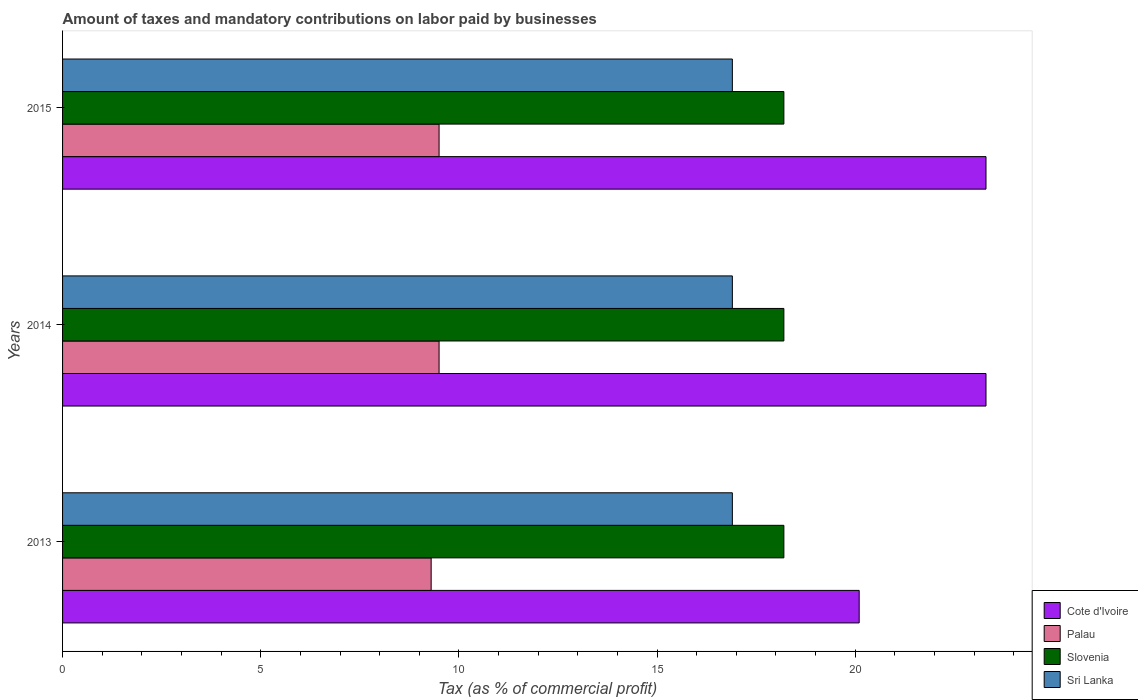Are the number of bars per tick equal to the number of legend labels?
Your answer should be compact. Yes. How many bars are there on the 3rd tick from the bottom?
Provide a succinct answer. 4. In how many cases, is the number of bars for a given year not equal to the number of legend labels?
Your answer should be very brief. 0. What is the percentage of taxes paid by businesses in Cote d'Ivoire in 2013?
Give a very brief answer. 20.1. Across all years, what is the maximum percentage of taxes paid by businesses in Sri Lanka?
Ensure brevity in your answer.  16.9. Across all years, what is the minimum percentage of taxes paid by businesses in Sri Lanka?
Your response must be concise. 16.9. What is the total percentage of taxes paid by businesses in Palau in the graph?
Offer a very short reply. 28.3. What is the difference between the percentage of taxes paid by businesses in Palau in 2013 and that in 2014?
Offer a terse response. -0.2. What is the difference between the percentage of taxes paid by businesses in Cote d'Ivoire in 2013 and the percentage of taxes paid by businesses in Slovenia in 2015?
Keep it short and to the point. 1.9. What is the average percentage of taxes paid by businesses in Cote d'Ivoire per year?
Your answer should be very brief. 22.23. In the year 2014, what is the difference between the percentage of taxes paid by businesses in Slovenia and percentage of taxes paid by businesses in Palau?
Your answer should be very brief. 8.7. Is the percentage of taxes paid by businesses in Cote d'Ivoire in 2013 less than that in 2014?
Your response must be concise. Yes. Is the difference between the percentage of taxes paid by businesses in Slovenia in 2014 and 2015 greater than the difference between the percentage of taxes paid by businesses in Palau in 2014 and 2015?
Offer a very short reply. No. What is the difference between the highest and the second highest percentage of taxes paid by businesses in Cote d'Ivoire?
Make the answer very short. 0. What is the difference between the highest and the lowest percentage of taxes paid by businesses in Cote d'Ivoire?
Make the answer very short. 3.2. Is the sum of the percentage of taxes paid by businesses in Palau in 2013 and 2014 greater than the maximum percentage of taxes paid by businesses in Cote d'Ivoire across all years?
Offer a terse response. No. What does the 4th bar from the top in 2015 represents?
Offer a very short reply. Cote d'Ivoire. What does the 4th bar from the bottom in 2013 represents?
Provide a succinct answer. Sri Lanka. Is it the case that in every year, the sum of the percentage of taxes paid by businesses in Cote d'Ivoire and percentage of taxes paid by businesses in Slovenia is greater than the percentage of taxes paid by businesses in Sri Lanka?
Ensure brevity in your answer.  Yes. How many bars are there?
Offer a terse response. 12. Are all the bars in the graph horizontal?
Keep it short and to the point. Yes. Are the values on the major ticks of X-axis written in scientific E-notation?
Your answer should be very brief. No. Does the graph contain any zero values?
Keep it short and to the point. No. Does the graph contain grids?
Your answer should be very brief. No. How are the legend labels stacked?
Your response must be concise. Vertical. What is the title of the graph?
Provide a short and direct response. Amount of taxes and mandatory contributions on labor paid by businesses. Does "Benin" appear as one of the legend labels in the graph?
Provide a short and direct response. No. What is the label or title of the X-axis?
Ensure brevity in your answer.  Tax (as % of commercial profit). What is the Tax (as % of commercial profit) in Cote d'Ivoire in 2013?
Give a very brief answer. 20.1. What is the Tax (as % of commercial profit) of Palau in 2013?
Offer a terse response. 9.3. What is the Tax (as % of commercial profit) of Slovenia in 2013?
Offer a terse response. 18.2. What is the Tax (as % of commercial profit) of Cote d'Ivoire in 2014?
Offer a terse response. 23.3. What is the Tax (as % of commercial profit) in Sri Lanka in 2014?
Offer a terse response. 16.9. What is the Tax (as % of commercial profit) of Cote d'Ivoire in 2015?
Offer a terse response. 23.3. What is the Tax (as % of commercial profit) in Palau in 2015?
Your response must be concise. 9.5. What is the Tax (as % of commercial profit) of Sri Lanka in 2015?
Offer a very short reply. 16.9. Across all years, what is the maximum Tax (as % of commercial profit) in Cote d'Ivoire?
Your response must be concise. 23.3. Across all years, what is the maximum Tax (as % of commercial profit) in Palau?
Your response must be concise. 9.5. Across all years, what is the maximum Tax (as % of commercial profit) of Sri Lanka?
Provide a succinct answer. 16.9. Across all years, what is the minimum Tax (as % of commercial profit) in Cote d'Ivoire?
Provide a short and direct response. 20.1. Across all years, what is the minimum Tax (as % of commercial profit) in Slovenia?
Provide a succinct answer. 18.2. What is the total Tax (as % of commercial profit) in Cote d'Ivoire in the graph?
Make the answer very short. 66.7. What is the total Tax (as % of commercial profit) of Palau in the graph?
Your answer should be very brief. 28.3. What is the total Tax (as % of commercial profit) of Slovenia in the graph?
Give a very brief answer. 54.6. What is the total Tax (as % of commercial profit) in Sri Lanka in the graph?
Make the answer very short. 50.7. What is the difference between the Tax (as % of commercial profit) of Palau in 2013 and that in 2014?
Offer a terse response. -0.2. What is the difference between the Tax (as % of commercial profit) in Slovenia in 2013 and that in 2014?
Your answer should be very brief. 0. What is the difference between the Tax (as % of commercial profit) of Sri Lanka in 2013 and that in 2014?
Make the answer very short. 0. What is the difference between the Tax (as % of commercial profit) in Slovenia in 2013 and that in 2015?
Make the answer very short. 0. What is the difference between the Tax (as % of commercial profit) in Slovenia in 2014 and that in 2015?
Provide a short and direct response. 0. What is the difference between the Tax (as % of commercial profit) in Cote d'Ivoire in 2013 and the Tax (as % of commercial profit) in Palau in 2014?
Give a very brief answer. 10.6. What is the difference between the Tax (as % of commercial profit) in Cote d'Ivoire in 2013 and the Tax (as % of commercial profit) in Slovenia in 2014?
Provide a succinct answer. 1.9. What is the difference between the Tax (as % of commercial profit) in Palau in 2013 and the Tax (as % of commercial profit) in Slovenia in 2014?
Your answer should be very brief. -8.9. What is the difference between the Tax (as % of commercial profit) of Slovenia in 2013 and the Tax (as % of commercial profit) of Sri Lanka in 2014?
Offer a very short reply. 1.3. What is the difference between the Tax (as % of commercial profit) in Cote d'Ivoire in 2013 and the Tax (as % of commercial profit) in Palau in 2015?
Offer a terse response. 10.6. What is the difference between the Tax (as % of commercial profit) of Cote d'Ivoire in 2013 and the Tax (as % of commercial profit) of Slovenia in 2015?
Ensure brevity in your answer.  1.9. What is the difference between the Tax (as % of commercial profit) of Cote d'Ivoire in 2013 and the Tax (as % of commercial profit) of Sri Lanka in 2015?
Make the answer very short. 3.2. What is the difference between the Tax (as % of commercial profit) of Palau in 2013 and the Tax (as % of commercial profit) of Slovenia in 2015?
Provide a succinct answer. -8.9. What is the difference between the Tax (as % of commercial profit) of Palau in 2013 and the Tax (as % of commercial profit) of Sri Lanka in 2015?
Ensure brevity in your answer.  -7.6. What is the difference between the Tax (as % of commercial profit) in Slovenia in 2013 and the Tax (as % of commercial profit) in Sri Lanka in 2015?
Make the answer very short. 1.3. What is the difference between the Tax (as % of commercial profit) in Cote d'Ivoire in 2014 and the Tax (as % of commercial profit) in Sri Lanka in 2015?
Provide a short and direct response. 6.4. What is the difference between the Tax (as % of commercial profit) in Palau in 2014 and the Tax (as % of commercial profit) in Sri Lanka in 2015?
Offer a terse response. -7.4. What is the average Tax (as % of commercial profit) in Cote d'Ivoire per year?
Keep it short and to the point. 22.23. What is the average Tax (as % of commercial profit) of Palau per year?
Give a very brief answer. 9.43. What is the average Tax (as % of commercial profit) in Slovenia per year?
Provide a succinct answer. 18.2. What is the average Tax (as % of commercial profit) of Sri Lanka per year?
Offer a very short reply. 16.9. In the year 2013, what is the difference between the Tax (as % of commercial profit) in Cote d'Ivoire and Tax (as % of commercial profit) in Palau?
Your answer should be very brief. 10.8. In the year 2013, what is the difference between the Tax (as % of commercial profit) in Cote d'Ivoire and Tax (as % of commercial profit) in Slovenia?
Make the answer very short. 1.9. In the year 2013, what is the difference between the Tax (as % of commercial profit) of Cote d'Ivoire and Tax (as % of commercial profit) of Sri Lanka?
Offer a very short reply. 3.2. In the year 2013, what is the difference between the Tax (as % of commercial profit) of Palau and Tax (as % of commercial profit) of Sri Lanka?
Ensure brevity in your answer.  -7.6. In the year 2013, what is the difference between the Tax (as % of commercial profit) of Slovenia and Tax (as % of commercial profit) of Sri Lanka?
Keep it short and to the point. 1.3. In the year 2014, what is the difference between the Tax (as % of commercial profit) in Cote d'Ivoire and Tax (as % of commercial profit) in Palau?
Provide a succinct answer. 13.8. In the year 2014, what is the difference between the Tax (as % of commercial profit) of Cote d'Ivoire and Tax (as % of commercial profit) of Slovenia?
Give a very brief answer. 5.1. In the year 2014, what is the difference between the Tax (as % of commercial profit) of Cote d'Ivoire and Tax (as % of commercial profit) of Sri Lanka?
Make the answer very short. 6.4. In the year 2014, what is the difference between the Tax (as % of commercial profit) in Palau and Tax (as % of commercial profit) in Slovenia?
Keep it short and to the point. -8.7. In the year 2014, what is the difference between the Tax (as % of commercial profit) of Palau and Tax (as % of commercial profit) of Sri Lanka?
Provide a short and direct response. -7.4. In the year 2015, what is the difference between the Tax (as % of commercial profit) of Palau and Tax (as % of commercial profit) of Sri Lanka?
Provide a succinct answer. -7.4. What is the ratio of the Tax (as % of commercial profit) in Cote d'Ivoire in 2013 to that in 2014?
Provide a succinct answer. 0.86. What is the ratio of the Tax (as % of commercial profit) of Palau in 2013 to that in 2014?
Provide a succinct answer. 0.98. What is the ratio of the Tax (as % of commercial profit) of Slovenia in 2013 to that in 2014?
Your answer should be compact. 1. What is the ratio of the Tax (as % of commercial profit) of Cote d'Ivoire in 2013 to that in 2015?
Offer a very short reply. 0.86. What is the ratio of the Tax (as % of commercial profit) in Palau in 2013 to that in 2015?
Ensure brevity in your answer.  0.98. What is the ratio of the Tax (as % of commercial profit) of Slovenia in 2013 to that in 2015?
Make the answer very short. 1. What is the ratio of the Tax (as % of commercial profit) of Sri Lanka in 2013 to that in 2015?
Offer a terse response. 1. What is the ratio of the Tax (as % of commercial profit) in Cote d'Ivoire in 2014 to that in 2015?
Provide a short and direct response. 1. What is the ratio of the Tax (as % of commercial profit) in Sri Lanka in 2014 to that in 2015?
Offer a very short reply. 1. What is the difference between the highest and the second highest Tax (as % of commercial profit) in Palau?
Your response must be concise. 0. What is the difference between the highest and the lowest Tax (as % of commercial profit) in Cote d'Ivoire?
Your answer should be very brief. 3.2. What is the difference between the highest and the lowest Tax (as % of commercial profit) of Slovenia?
Offer a terse response. 0. What is the difference between the highest and the lowest Tax (as % of commercial profit) in Sri Lanka?
Ensure brevity in your answer.  0. 